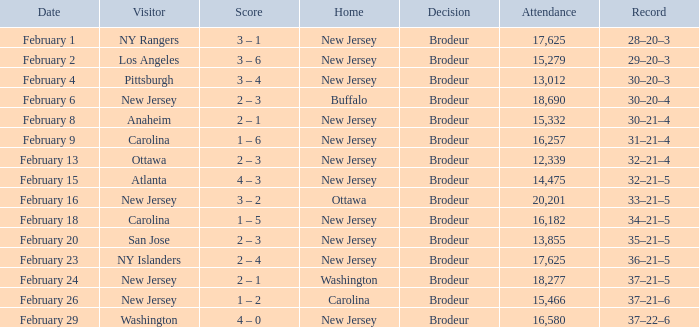What was the record when the visiting team was Ottawa? 32–21–4. 